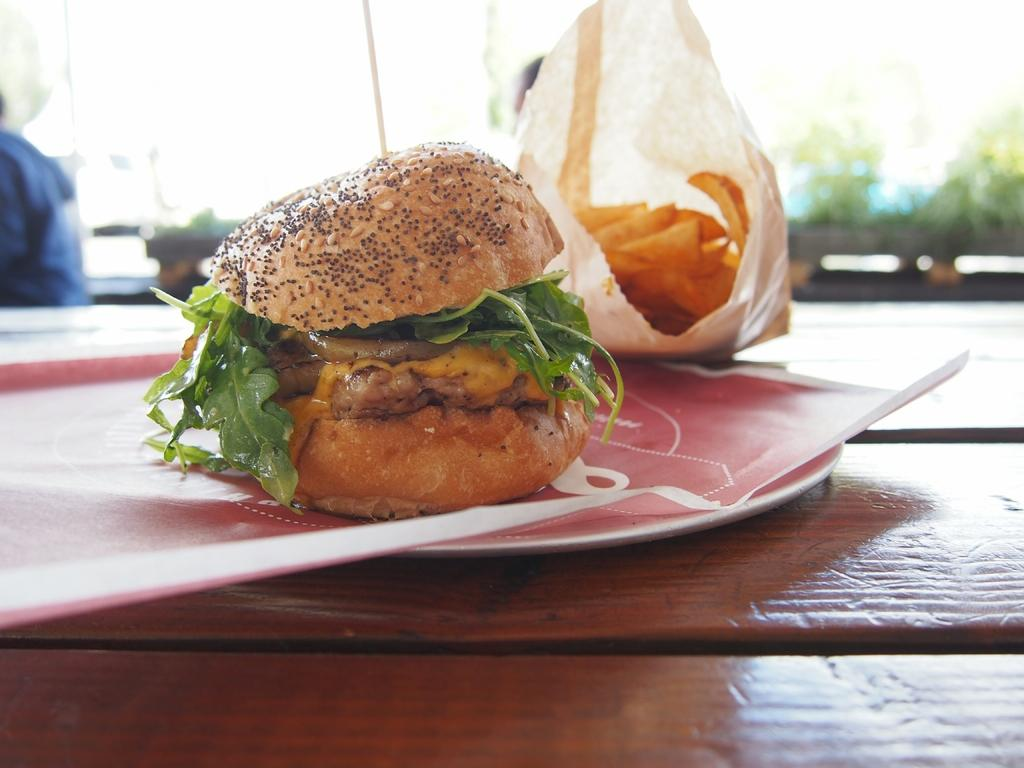What type of food is visible in the image? There is a burger in the image. What else is present on the table in the image? There is a cover with food, paper, and a plate on the table. What is the surface on which the burger, cover with food, paper, and plate are placed? The burger, cover with food, paper, and plate are on a table. Is there anyone else visible in the image besides the food items? Yes, there is a person in the background of the image. What channel is the person in the background watching on their thumb? There is no person watching a channel on their thumb in the image. The image only shows a burger, a cover with food, paper, a plate, and a person in the background. 